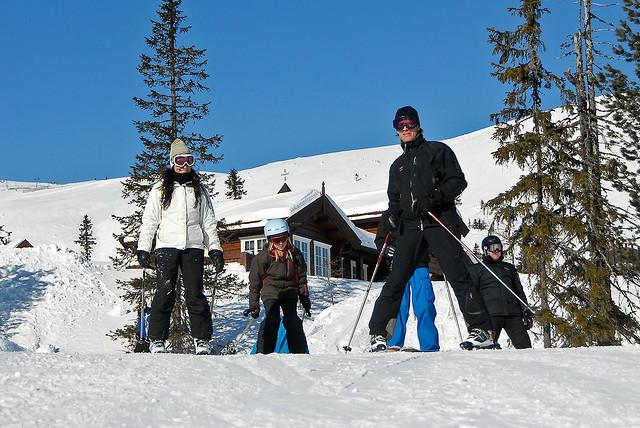Why are the children's heads covered? Please explain your reasoning. protection. The children are skiing. skiing is done in cold places with snow where exposed skin can be problematic and head injuries could happen which is why most skiers and especially beginners where helmets. 